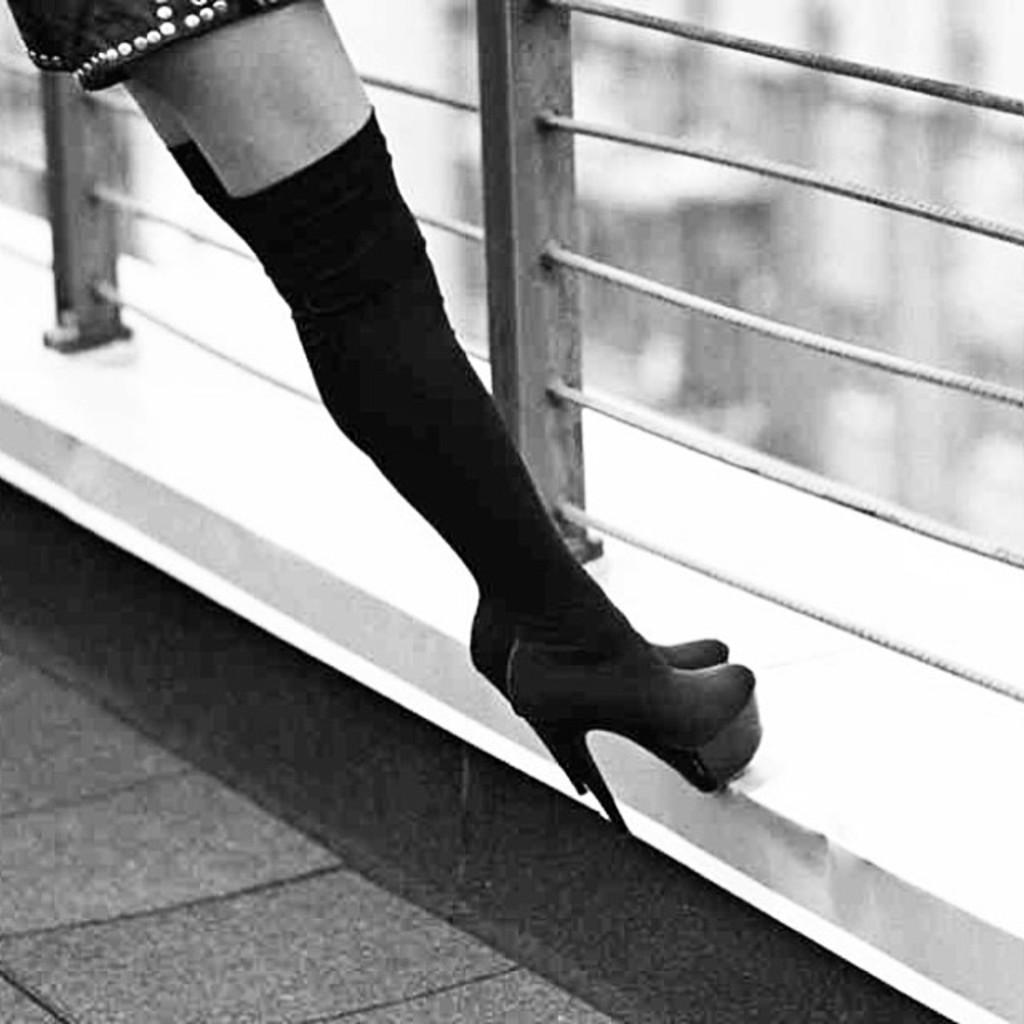What is the color scheme of the image? The image is in black and white. What can be seen in the image besides the color scheme? There is a person standing on a path, and there is a grill fence in front of the person. What type of window can be seen in the image? There is no window present in the image; it features a person standing on a path with a grill fence in front of them. Can you tell me how many pieces of quartz are visible in the image? There is no quartz present in the image. 